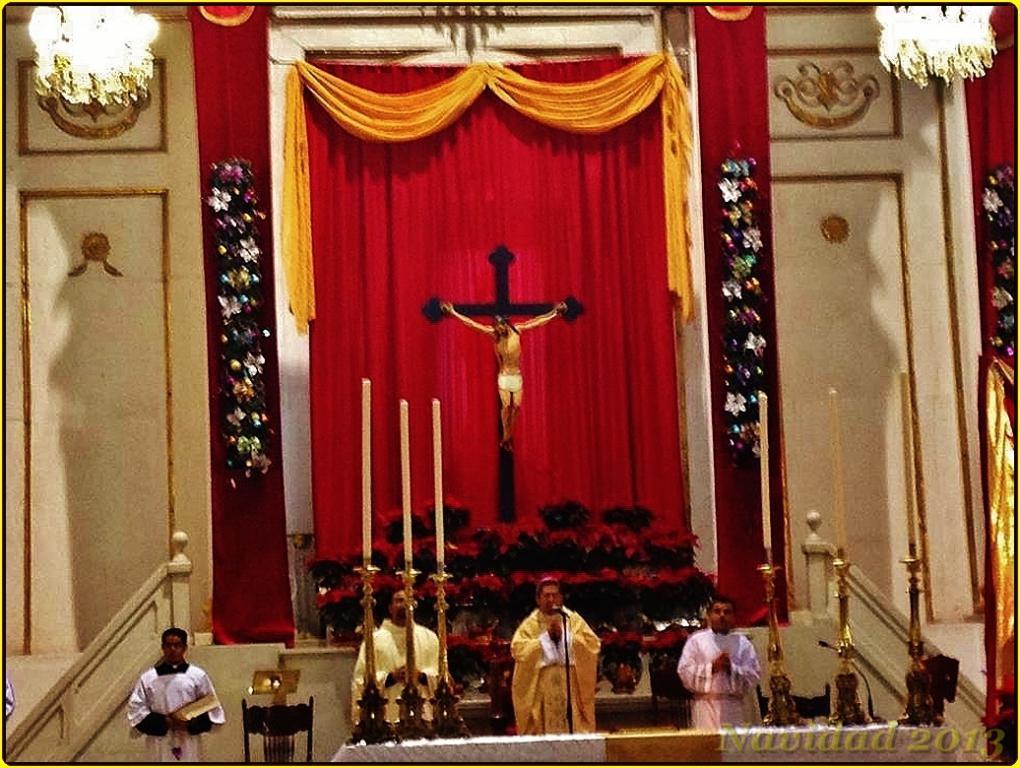Could you give a brief overview of what you see in this image? In the image we can see the internal structure of the church. We can see there are people standing and wearing clothes. Here we can see microphone on the stand, we can even see candles and metal objects. Here we can see cross symbol and sculpture of god. Here we can see two chandeliers and the curtains. 